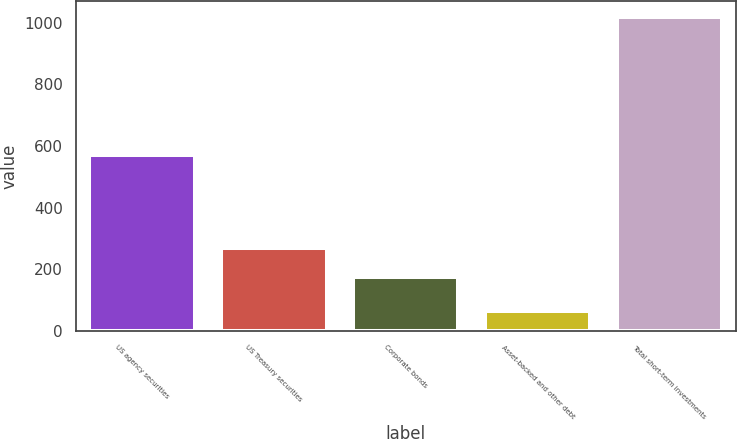Convert chart. <chart><loc_0><loc_0><loc_500><loc_500><bar_chart><fcel>US agency securities<fcel>US Treasury securities<fcel>Corporate bonds<fcel>Asset-backed and other debt<fcel>Total short-term investments<nl><fcel>571<fcel>270.4<fcel>175<fcel>65<fcel>1019<nl></chart> 